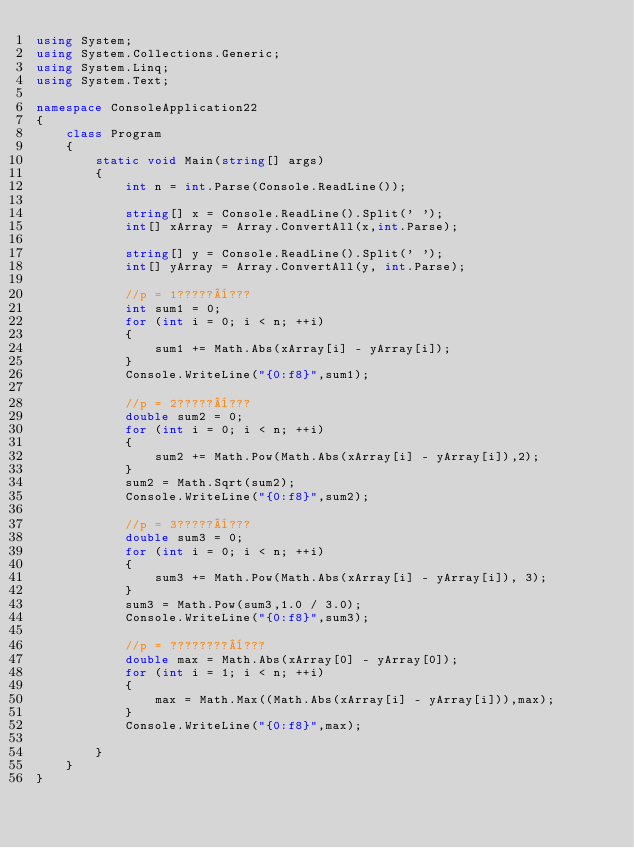Convert code to text. <code><loc_0><loc_0><loc_500><loc_500><_C#_>using System;
using System.Collections.Generic;
using System.Linq;
using System.Text;

namespace ConsoleApplication22
{
    class Program
    {
        static void Main(string[] args)
        {
            int n = int.Parse(Console.ReadLine());

            string[] x = Console.ReadLine().Split(' ');
            int[] xArray = Array.ConvertAll(x,int.Parse);

            string[] y = Console.ReadLine().Split(' ');
            int[] yArray = Array.ConvertAll(y, int.Parse);

            //p = 1?????¨???
            int sum1 = 0;
            for (int i = 0; i < n; ++i)
            {
                sum1 += Math.Abs(xArray[i] - yArray[i]);
            }
            Console.WriteLine("{0:f8}",sum1);

            //p = 2?????¨???
            double sum2 = 0;
            for (int i = 0; i < n; ++i)
            {
                sum2 += Math.Pow(Math.Abs(xArray[i] - yArray[i]),2);
            }
            sum2 = Math.Sqrt(sum2);
            Console.WriteLine("{0:f8}",sum2);

            //p = 3?????¨???
            double sum3 = 0;
            for (int i = 0; i < n; ++i)
            {
                sum3 += Math.Pow(Math.Abs(xArray[i] - yArray[i]), 3);
            }
            sum3 = Math.Pow(sum3,1.0 / 3.0);
            Console.WriteLine("{0:f8}",sum3);

            //p = ????????¨???
            double max = Math.Abs(xArray[0] - yArray[0]);
            for (int i = 1; i < n; ++i)
            {
                max = Math.Max((Math.Abs(xArray[i] - yArray[i])),max);
            }
            Console.WriteLine("{0:f8}",max);

        }
    }
}</code> 